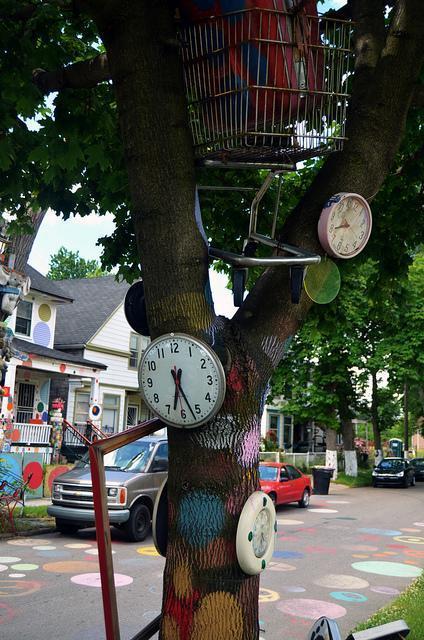How many clocks are on the tree?
Give a very brief answer. 3. How many clocks can you see?
Give a very brief answer. 3. 